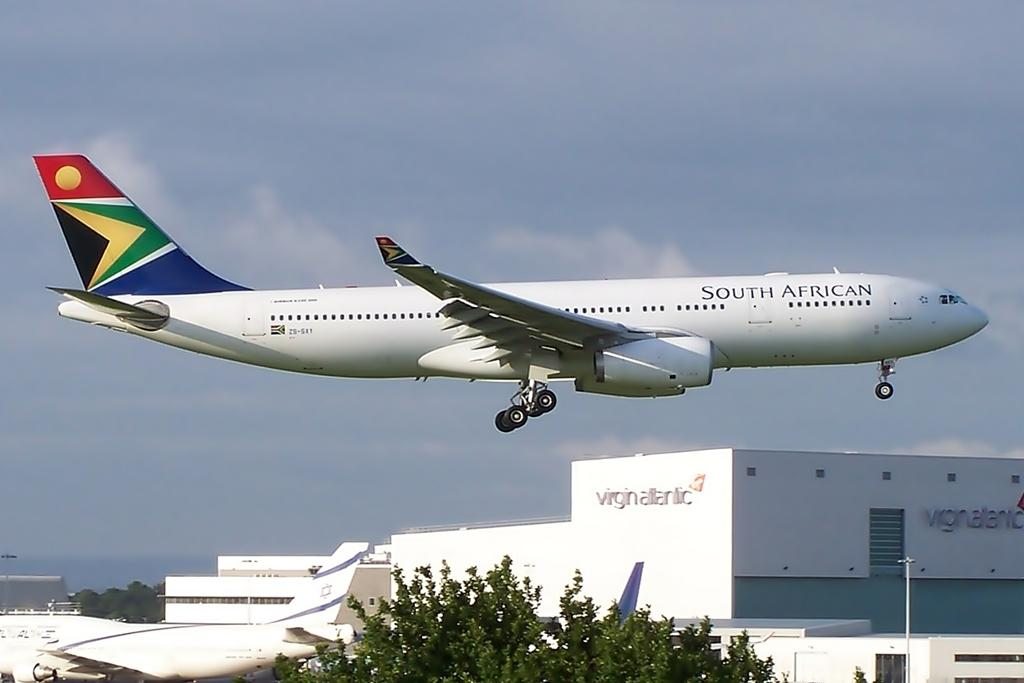<image>
Give a short and clear explanation of the subsequent image. A plane from South African airlines has just become airborne. 